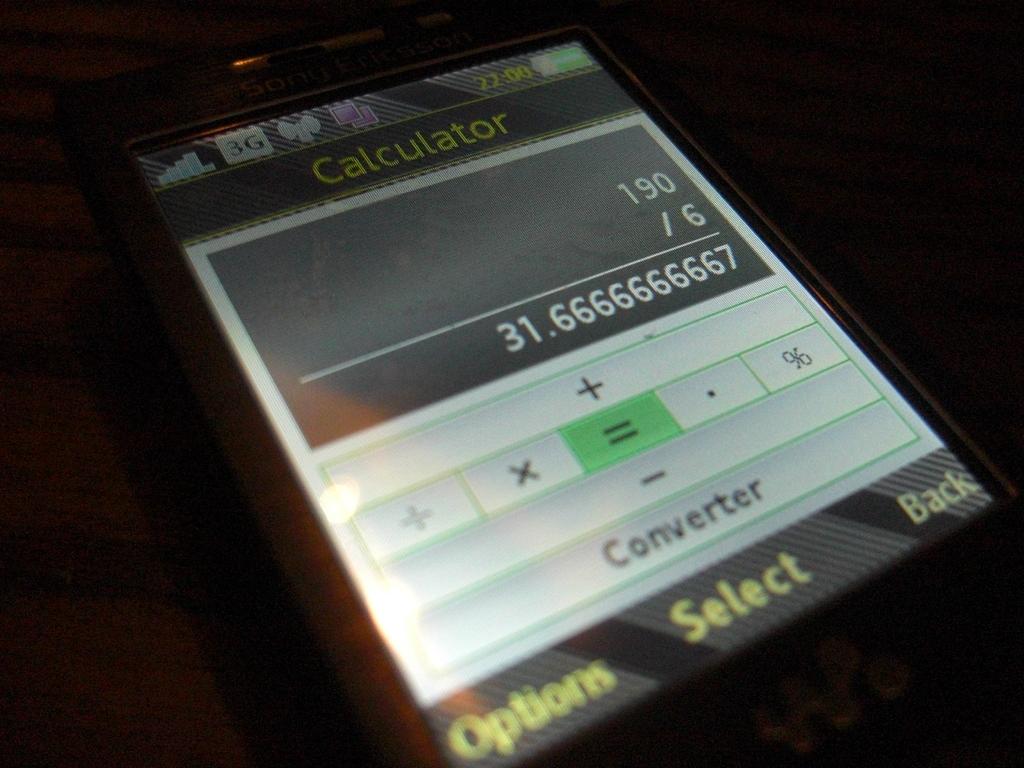What number is displayed in the answer box on the phone?
Offer a very short reply. 31.6666666667. What kind of app is being displayed?
Give a very brief answer. Calculator. 